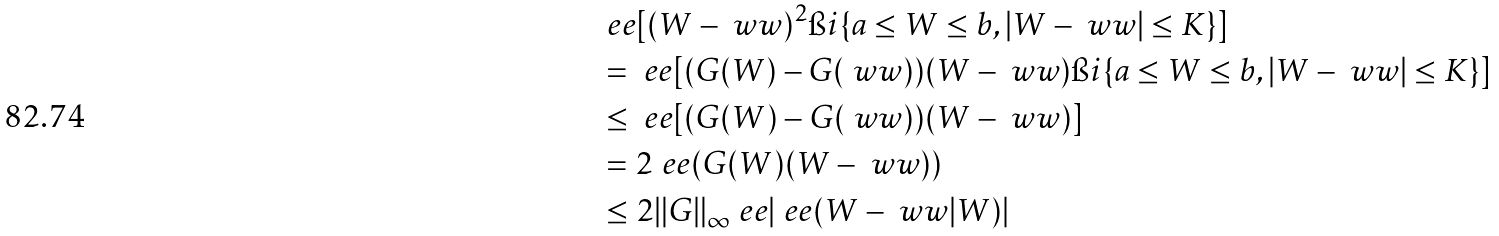<formula> <loc_0><loc_0><loc_500><loc_500>& \ e e [ ( W - \ w w ) ^ { 2 } \i i \{ a \leq W \leq b , | W - \ w w | \leq K \} ] \\ & = \ e e [ ( G ( W ) - G ( \ w w ) ) ( W - \ w w ) \i i \{ a \leq W \leq b , | W - \ w w | \leq K \} ] \\ & \leq \ e e [ ( G ( W ) - G ( \ w w ) ) ( W - \ w w ) ] \\ & = 2 \ e e ( G ( W ) ( W - \ w w ) ) \\ & \leq 2 \| G \| _ { \infty } \ e e | \ e e ( W - \ w w | W ) |</formula> 